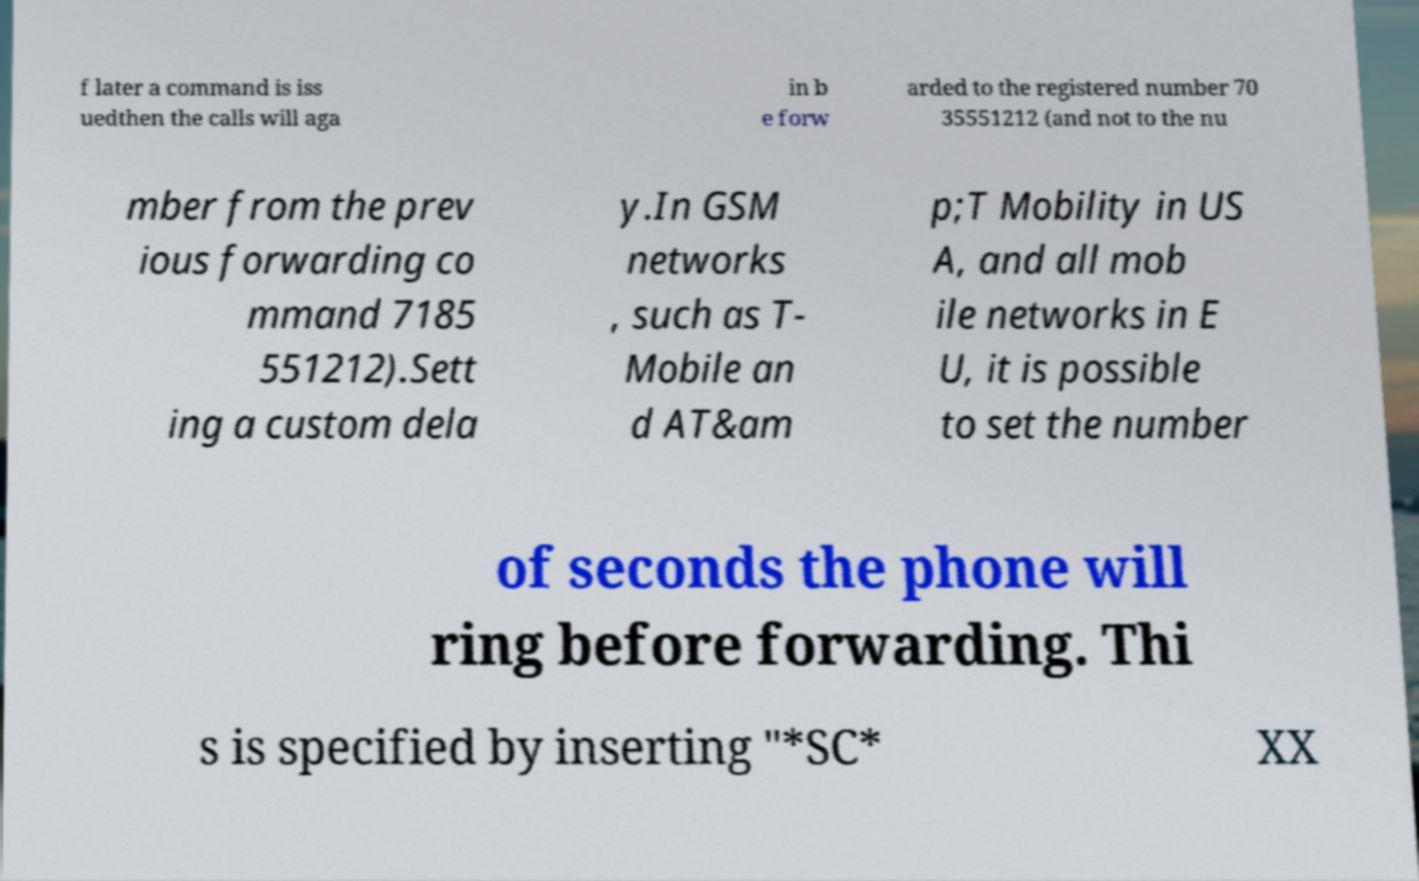Please identify and transcribe the text found in this image. f later a command is iss uedthen the calls will aga in b e forw arded to the registered number 70 35551212 (and not to the nu mber from the prev ious forwarding co mmand 7185 551212).Sett ing a custom dela y.In GSM networks , such as T- Mobile an d AT&am p;T Mobility in US A, and all mob ile networks in E U, it is possible to set the number of seconds the phone will ring before forwarding. Thi s is specified by inserting "*SC* XX 